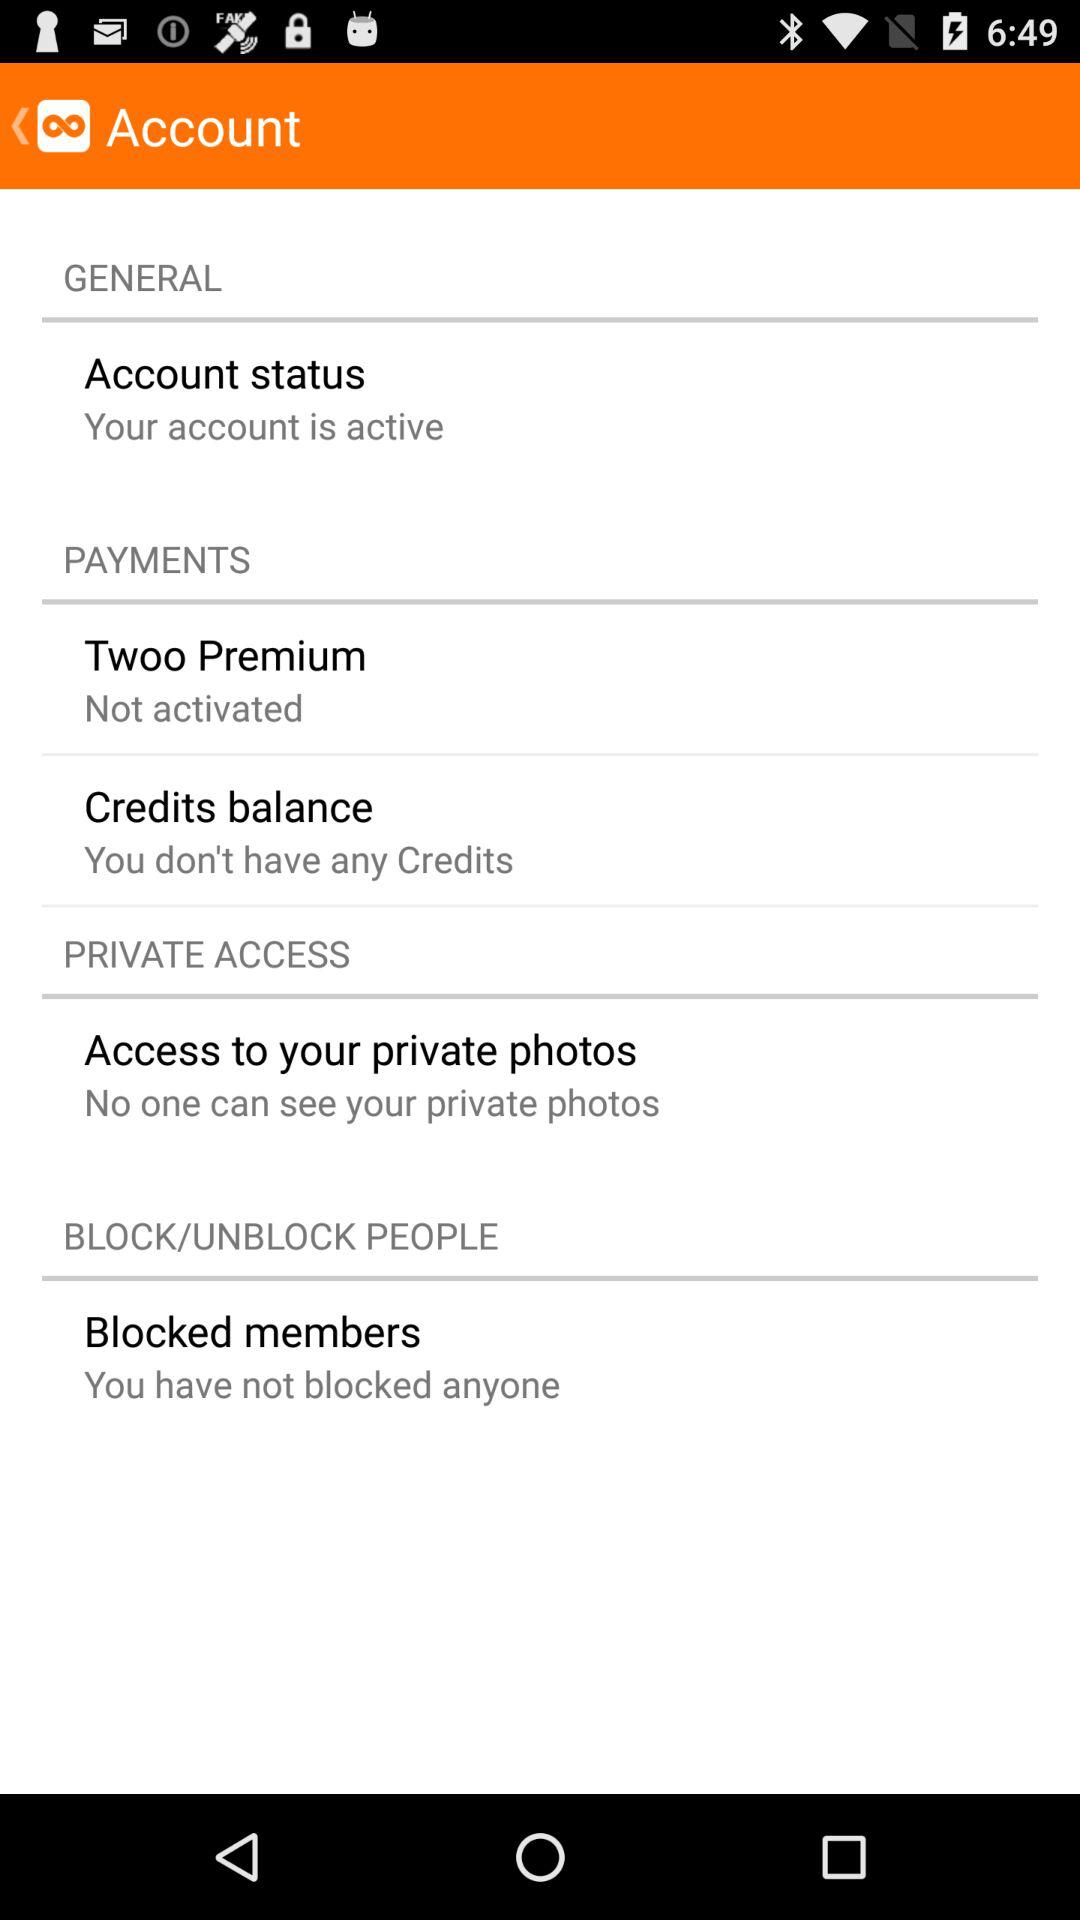How many more items are in the 'Payments' section than the 'Private Access' section?
Answer the question using a single word or phrase. 1 